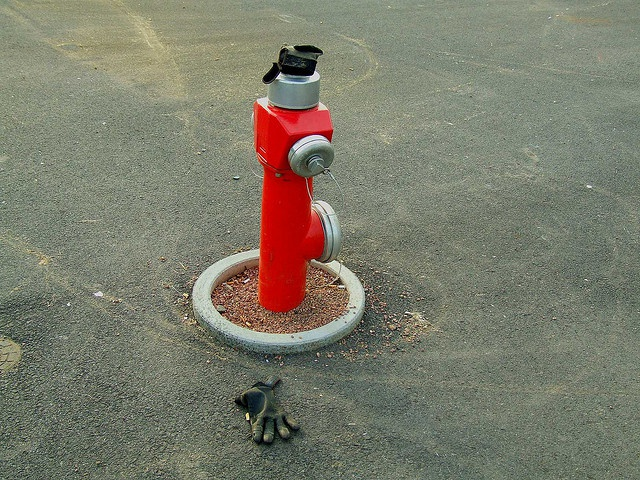Describe the objects in this image and their specific colors. I can see a fire hydrant in gray, brown, and black tones in this image. 